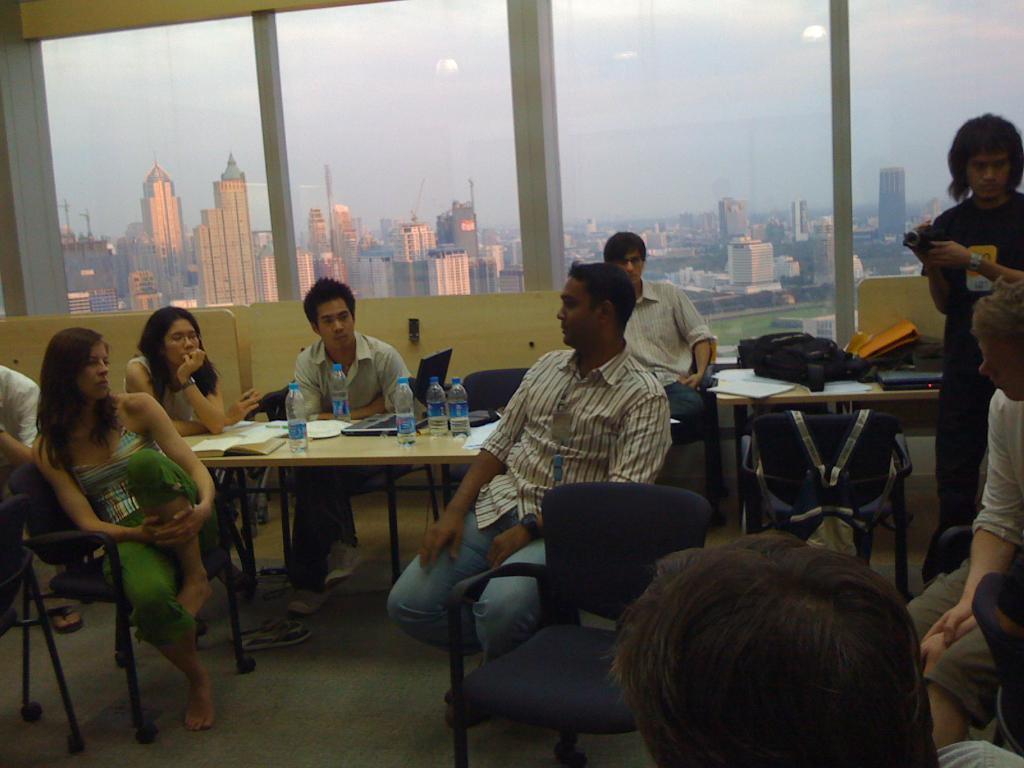How would you summarize this image in a sentence or two? in this picture we can see a group of people sitting on a chair, and in front there is the table and water bottles, and laptop on it ,and at back there is a person standing and holding a camera in his hand, and at back of him there are bags on the table ,and there is a glass, and we can see many buildings. 